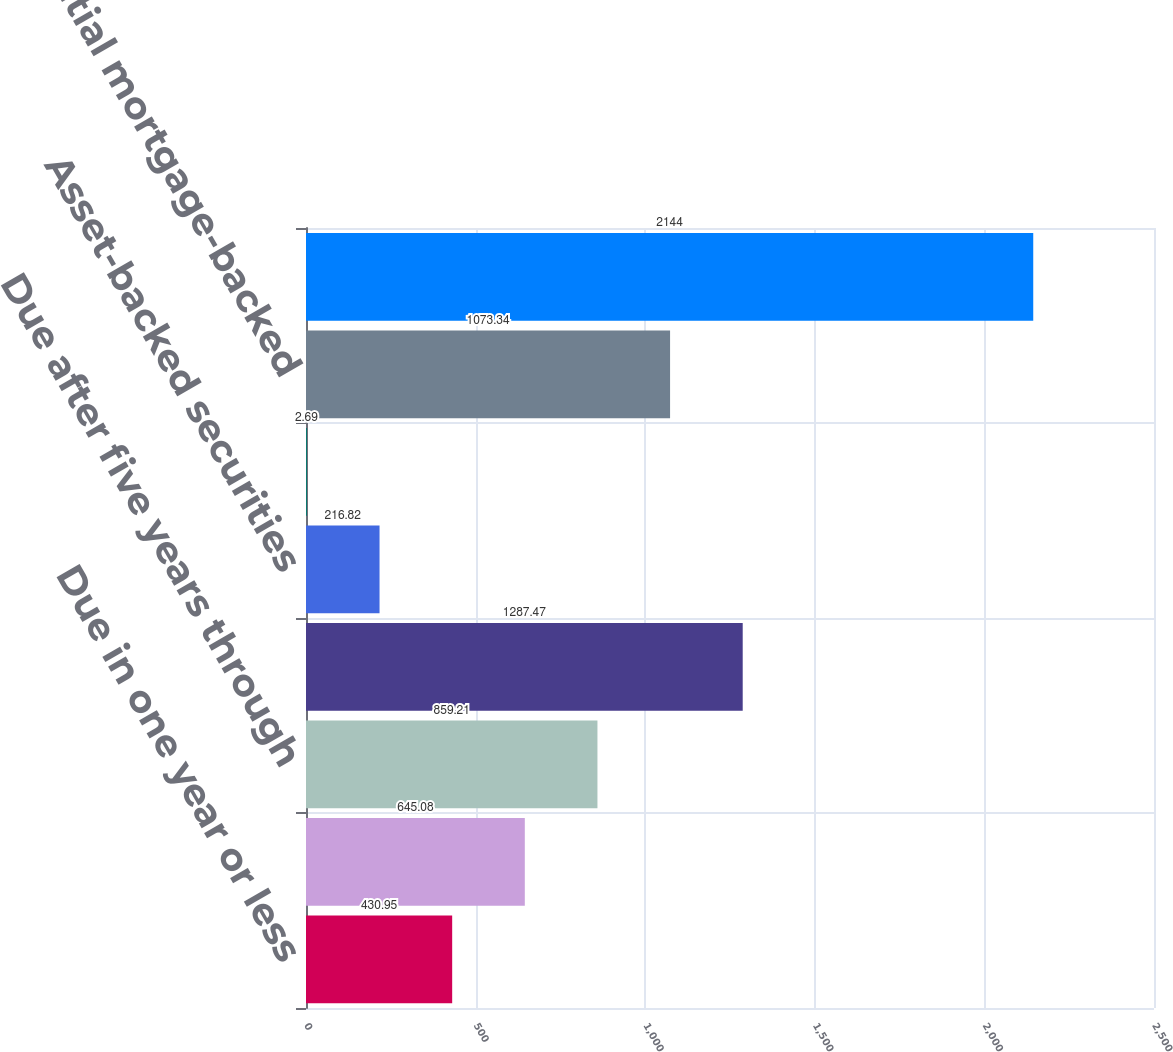Convert chart. <chart><loc_0><loc_0><loc_500><loc_500><bar_chart><fcel>Due in one year or less<fcel>Due after one year through<fcel>Due after five years through<fcel>Due after ten years(1)<fcel>Asset-backed securities<fcel>Commercial mortgage-backed<fcel>Residential mortgage-backed<fcel>Total<nl><fcel>430.95<fcel>645.08<fcel>859.21<fcel>1287.47<fcel>216.82<fcel>2.69<fcel>1073.34<fcel>2144<nl></chart> 